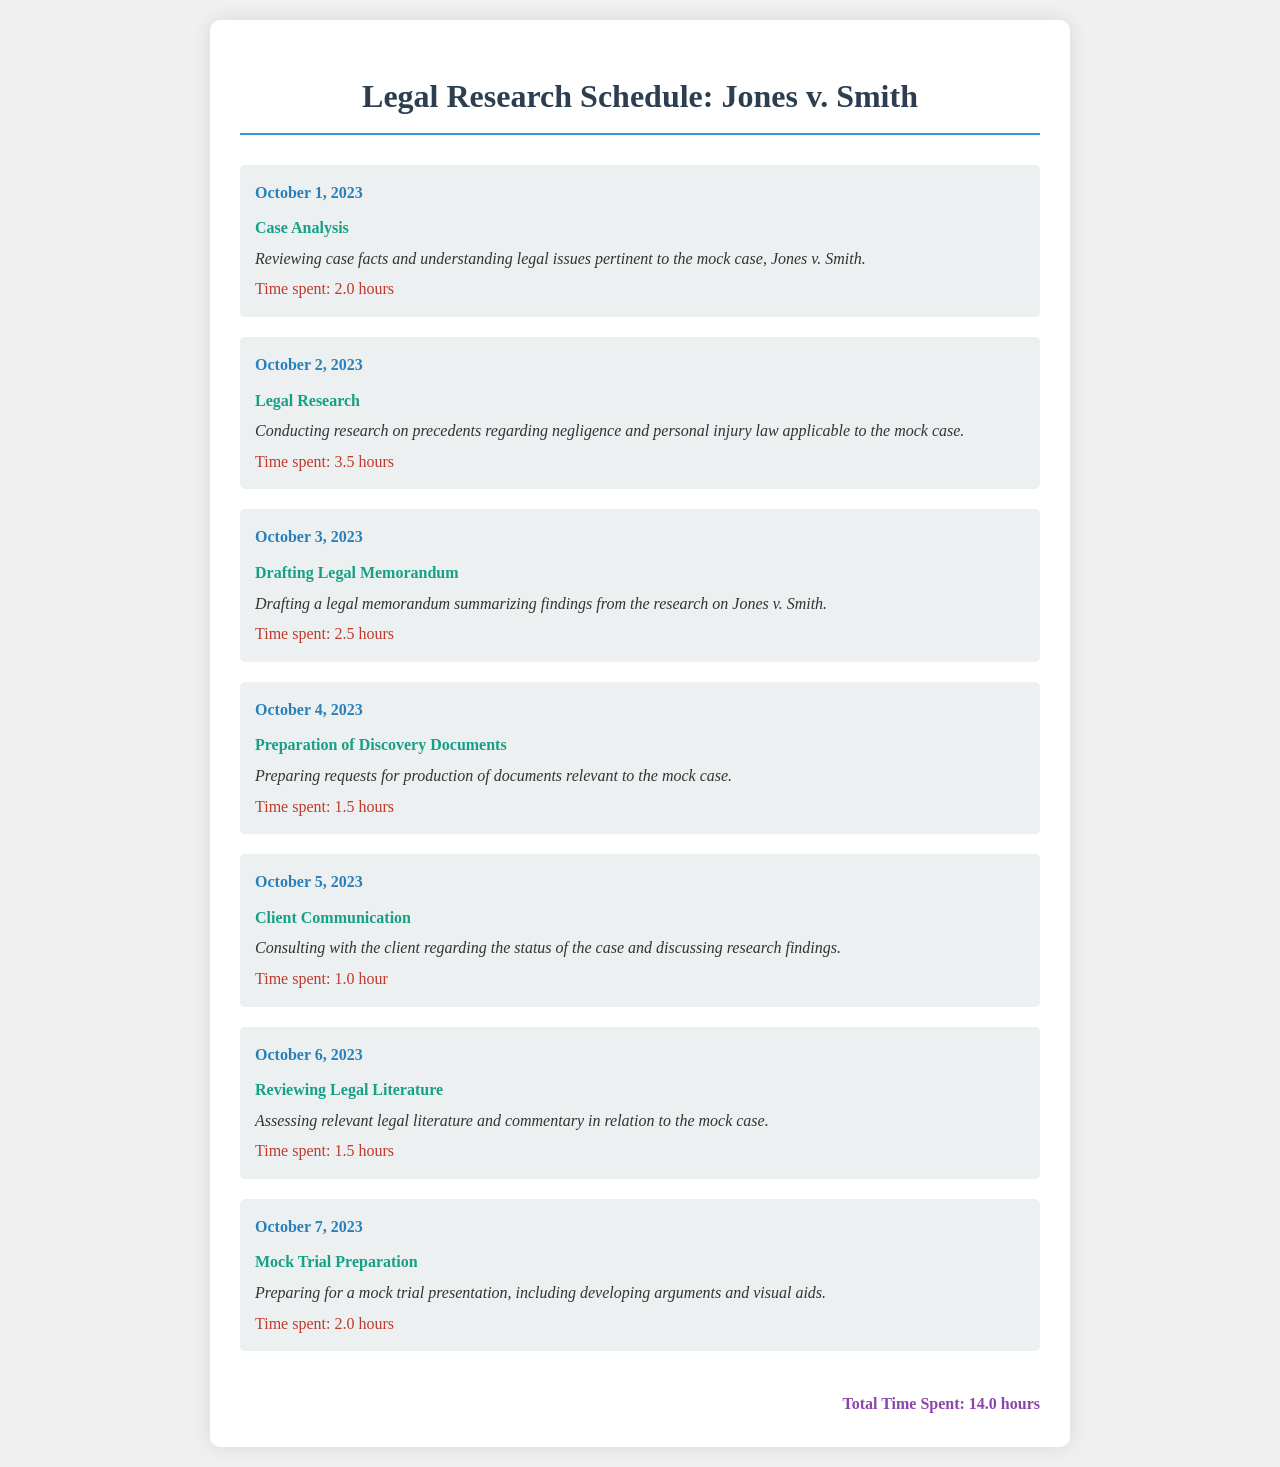What is the title of the case? The title of the case is stated prominently in the document.
Answer: Jones v. Smith What was the total time spent on legal research? The total time spent is listed at the end of the document, summarizing all time entries.
Answer: 14.0 hours How many hours were spent on the task of legal research? The specific time spent is noted under the task of legal research within the schedule.
Answer: 3.5 hours What date did the drafting of the legal memorandum occur? The specific date for drafting is provided in the schedule section for that task.
Answer: October 3, 2023 Which task required 1.0 hour? The duration for each task is noted along with the task description.
Answer: Client Communication What is the description for the preparation of discovery documents? The description gives details about the task's purpose and actions taken.
Answer: Preparing requests for production of documents relevant to the mock case On what date was case analysis conducted? The schedule clearly mentions the date for each task, including case analysis.
Answer: October 1, 2023 What is the color of the scheduled tasks' background? The background color for the task sections is consistent throughout the document.
Answer: Light gray Which task involved consulting with the client? The task names are clearly stated in the document under their respective dates.
Answer: Client Communication 